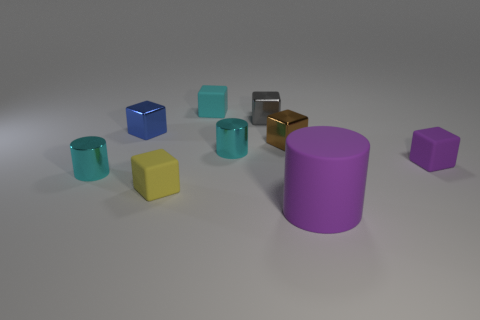Subtract all matte cylinders. How many cylinders are left? 2 Add 1 brown blocks. How many objects exist? 10 Subtract all cylinders. How many objects are left? 6 Subtract all cyan cylinders. How many cylinders are left? 1 Subtract 5 blocks. How many blocks are left? 1 Add 4 yellow matte things. How many yellow matte things exist? 5 Subtract 0 purple balls. How many objects are left? 9 Subtract all green cubes. Subtract all red cylinders. How many cubes are left? 6 Subtract all red blocks. How many green cylinders are left? 0 Subtract all big purple cylinders. Subtract all large yellow metal things. How many objects are left? 8 